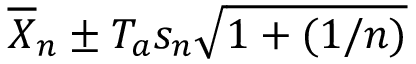<formula> <loc_0><loc_0><loc_500><loc_500>{ \overline { X } } _ { n } \pm T _ { a } s _ { n } { \sqrt { 1 + ( 1 / n ) } }</formula> 